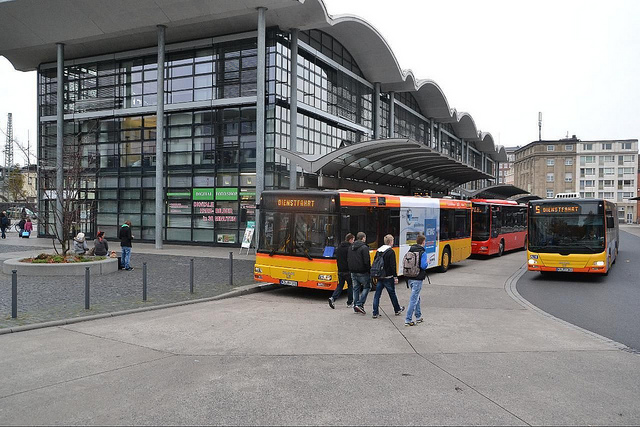Can you describe the weather or the season that this photo seems to be taken in? The photo suggests an overcast day with the absence of shadows and the presence of people wearing light jackets, hinting it could be during a cooler season like spring or autumn. 